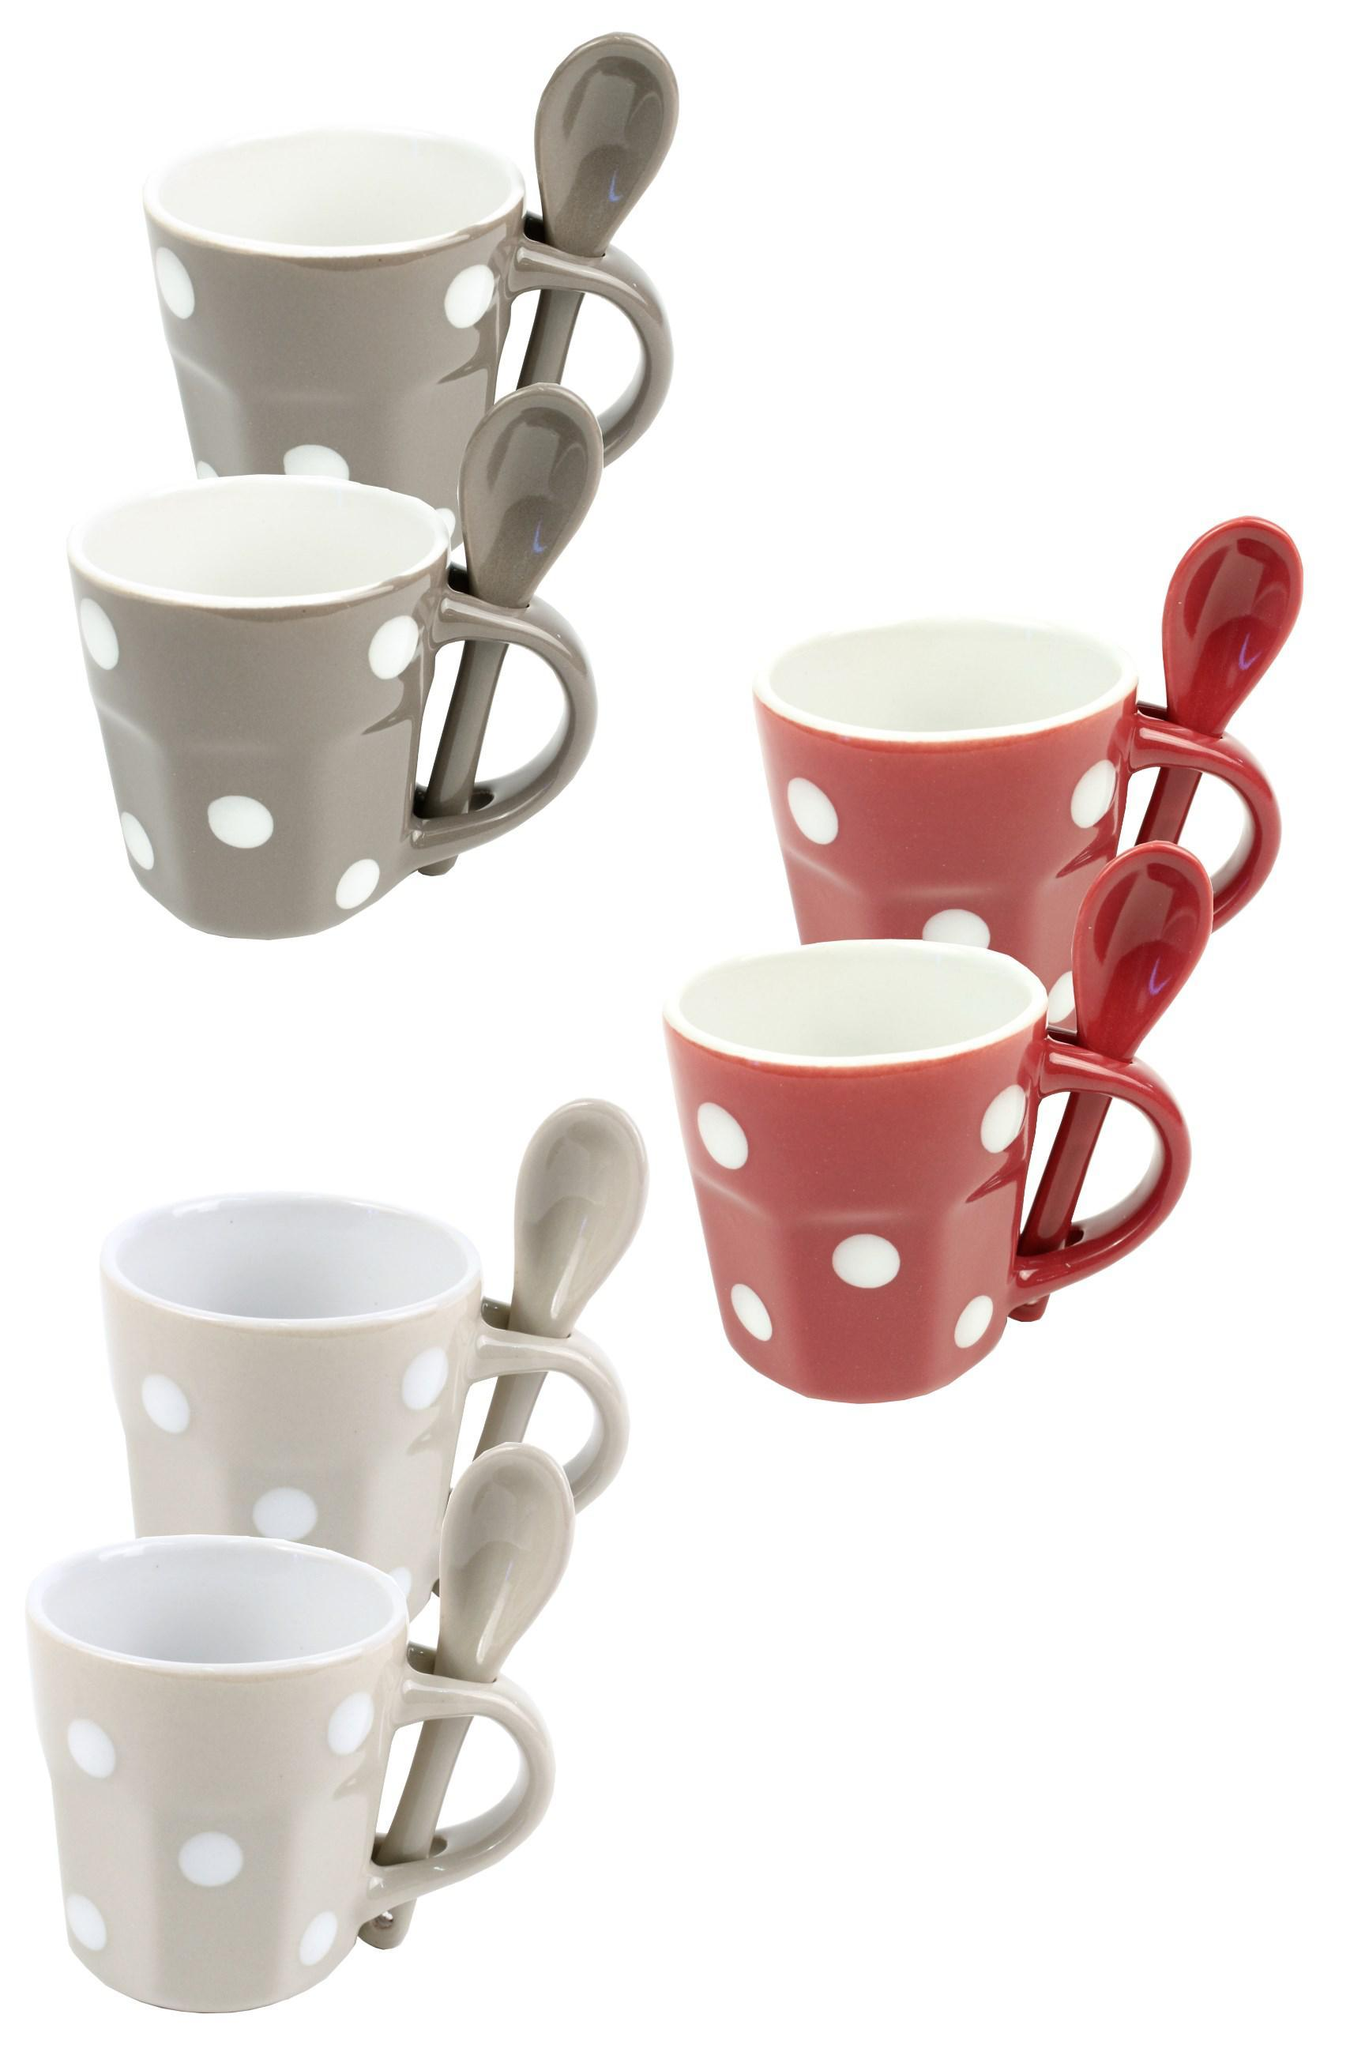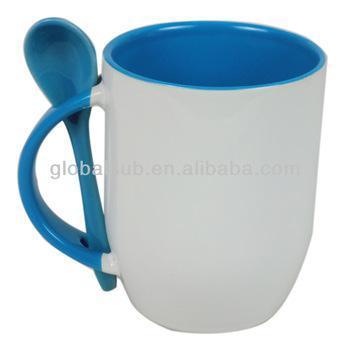The first image is the image on the left, the second image is the image on the right. Given the left and right images, does the statement "One image shows a single blue-lined white cup with a blue spoon." hold true? Answer yes or no. Yes. 